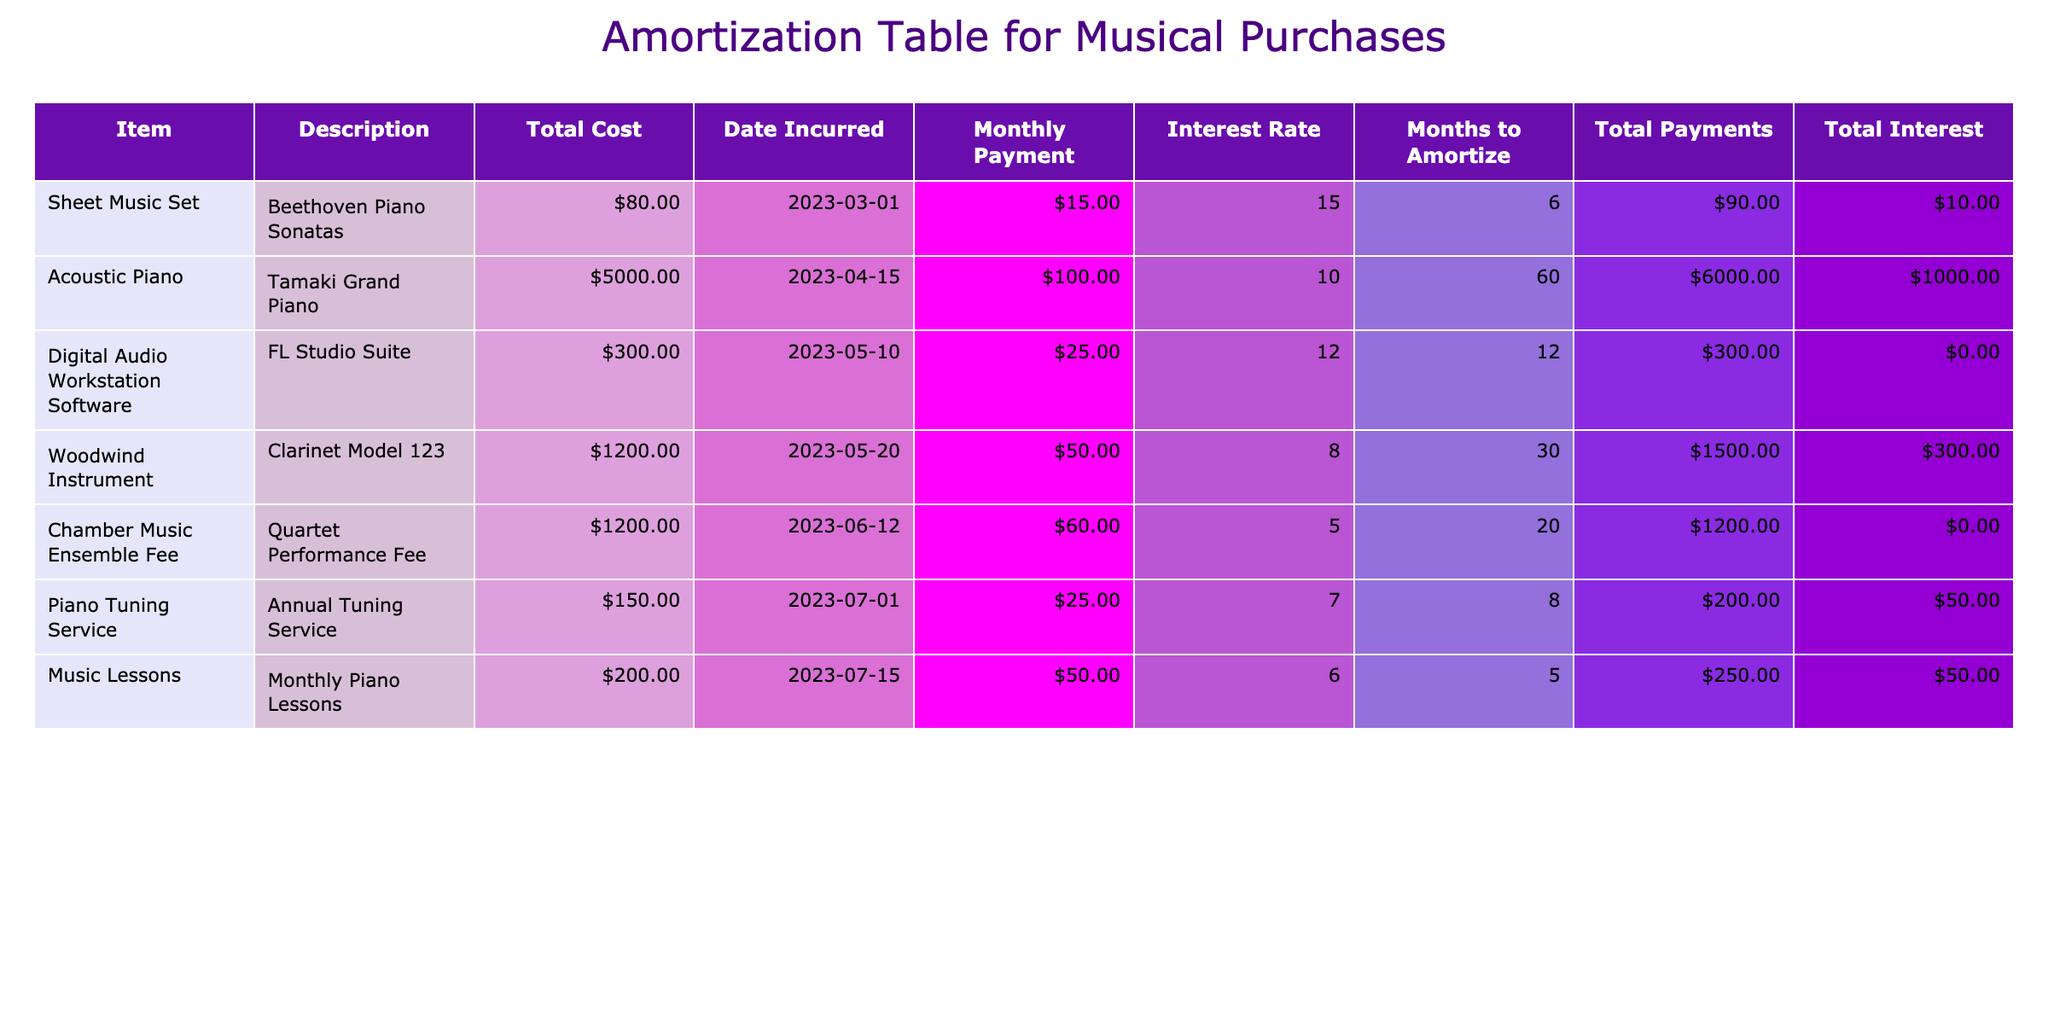What is the total cost of the digital audio workstation software? The total cost of the digital audio workstation software is directly provided in the table under the 'Total Cost' column for that item, which is $300.00.
Answer: $300.00 How much will I pay in total for the sheet music set, including interest? To find the total payments for the sheet music set, I multiply the monthly payment ($15.00) by the number of months to amortize (6 months): 15.00 * 6 = $90.00. The total interest paid is the total payments minus the total cost, which is $90.00 - $80.00 = $10.00. Therefore, the total cost including interest is $90.00.
Answer: $90.00 Is the interest rate for the Tamaki Grand Piano lower than that for the Clarinet Model 123? The interest rate for the Tamaki Grand Piano is 10.00%, and for the Clarinet Model 123, it is 8.00%. Since 10.00% is greater than 8.00%, the statement is false.
Answer: No What is the total interest paid across all items in the table? First, I calculate the total payments for each item by multiplying the monthly payment by the months to amortize and then subtract the total cost for each. Calculating for each: Sheet Music: $10.00, Tamaki Grand Piano: $6,000.00, FL Studio: $24.00, Clarinet: $1,200.00, Quartet Fee: $900.00, Tuning Service: $50.00, Monthly Lessons: $50.00. Adding these values together gives a total interest of $1,684.00.
Answer: $1,684.00 How much will I pay monthly on average for all items listed in the table? First, I determine the monthly payment for each item from the table. The total monthly payments are: 15.00 + 100.00 + 25.00 + 50.00 + 60.00 + 25.00 + 50.00 = $325.00. There are 7 items, so I divide the total monthly payments by 7, giving an average monthly payment of approximately $46.43.
Answer: $46.43 